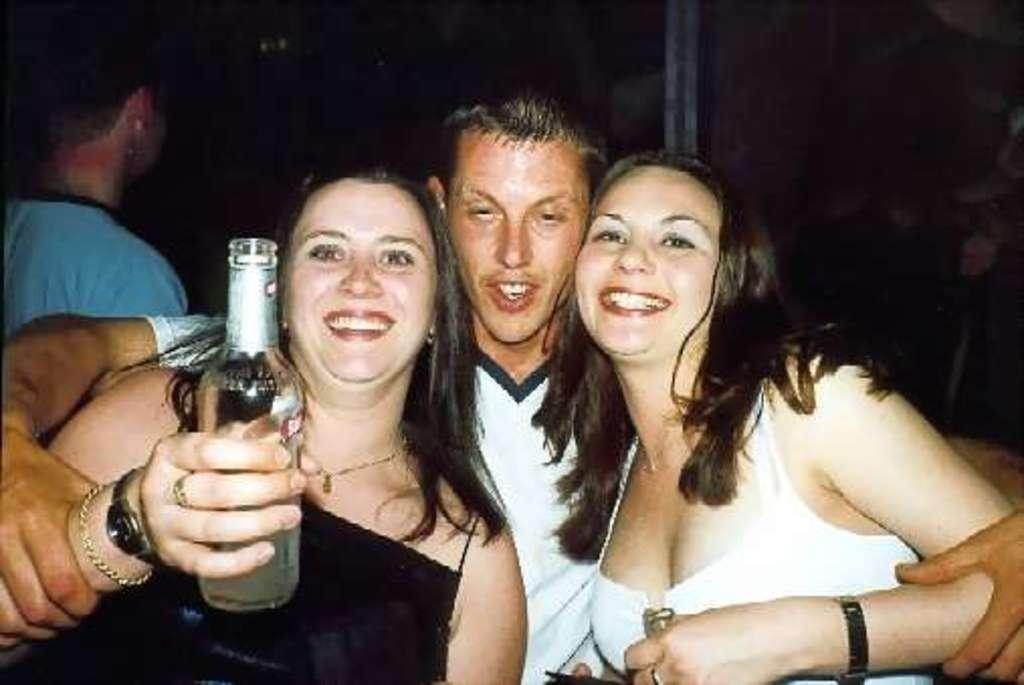How many people are present in the image? There are six people in the image. What are the people in the image doing? All four individuals are standing and smiling. Can you describe the additional woman in the image? The additional woman is holding a bottle in her hand. What is the color of the background in the image? The background of the image appears dark. What type of adjustment is being made to the flag in the image? There is no flag present in the image, so no adjustment can be made. How many people are missing from the image? There is no information about missing people in the image, so it cannot be determined. 